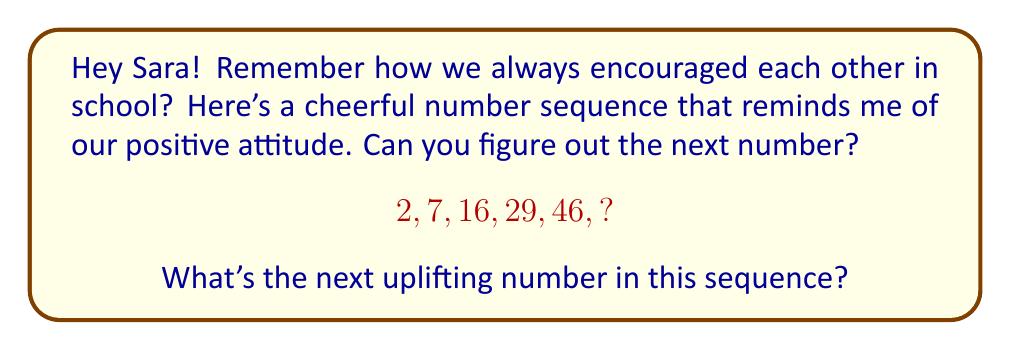What is the answer to this math problem? Let's approach this step-by-step, Sara!

1) First, let's look at the differences between consecutive terms:
   $7 - 2 = 5$
   $16 - 7 = 9$
   $29 - 16 = 13$
   $46 - 29 = 17$

2) We can see that the differences are increasing by 4 each time:
   $5, 9, 13, 17$

3) This pattern suggests that the next difference will be $17 + 4 = 21$

4) To find the next term in the original sequence, we add this difference to the last term:
   $46 + 21 = 67$

5) We can verify this by writing out the sequence of differences:
   $$\begin{align}
   2 &\xrightarrow{+5} 7 \\
   7 &\xrightarrow{+9} 16 \\
   16 &\xrightarrow{+13} 29 \\
   29 &\xrightarrow{+17} 46 \\
   46 &\xrightarrow{+21} 67
   \end{align}$$

6) This sequence is uplifting because each term is growing faster than the last, just like how our positivity grows stronger over time!
Answer: 67 